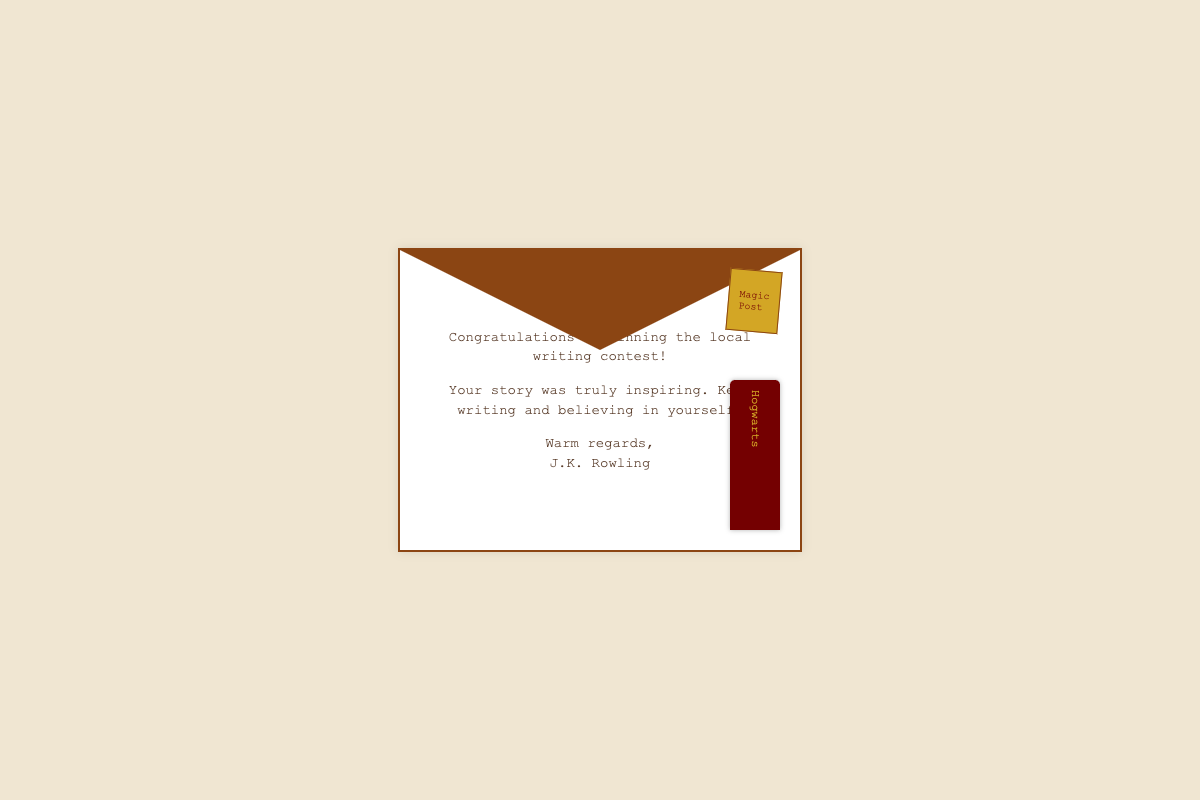what is the author’s name? The author of the letter is mentioned at the end of the letter, which is J.K. Rowling.
Answer: J.K. Rowling what contest did Emily win? The contest referred to in the letter is a local writing contest, as stated in the congratulatory message.
Answer: local writing contest what does the bookmark say? The content on the bookmark is "Hogwarts," as indicated in the visual representation.
Answer: Hogwarts how is the author's tone described? The author's tone is warm and encouraging, as shown by the choice of words used in the letter.
Answer: warm what is the color of the envelope's stamp? The stamp's color is yellow, as seen in the render of the envelope.
Answer: yellow how many paragraphs are in the letter? The letter contains three paragraphs that congratulate and encourage Emily.
Answer: three where is the bookmark located? The bookmark is positioned at the bottom right of the envelope, as illustrated in the design elements.
Answer: bottom right what type of document is this? This document is styled as an envelope containing a congratulatory letter.
Answer: envelope 